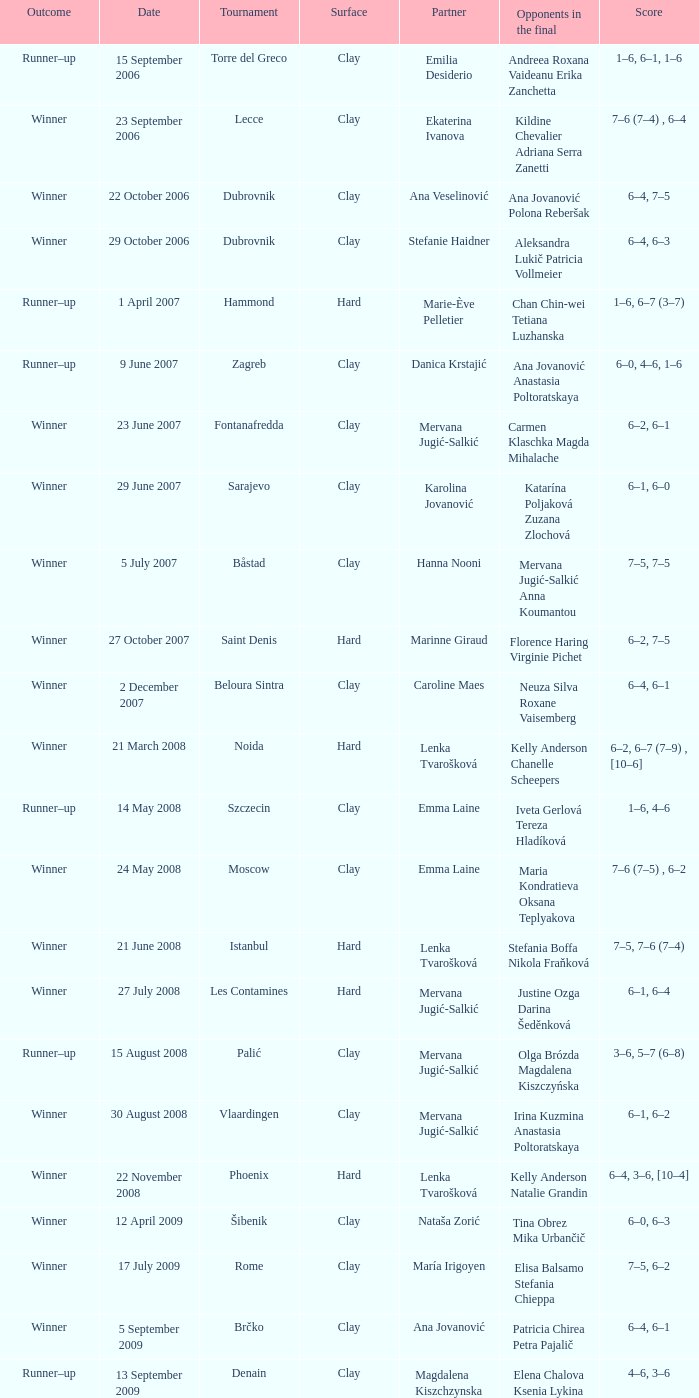What event featured a partner of erika sema? Aschaffenburg. 